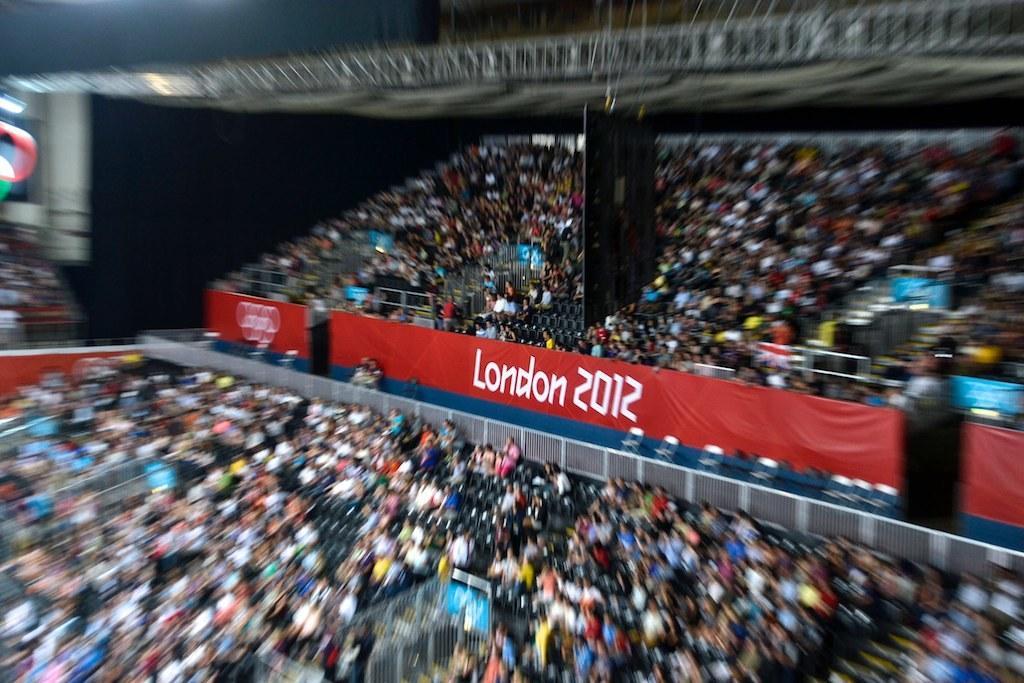Please provide a concise description of this image. In this image we can see many people sitting on the stands. We can also see the red color banner with text and also the year and some part of the image is blurred. 